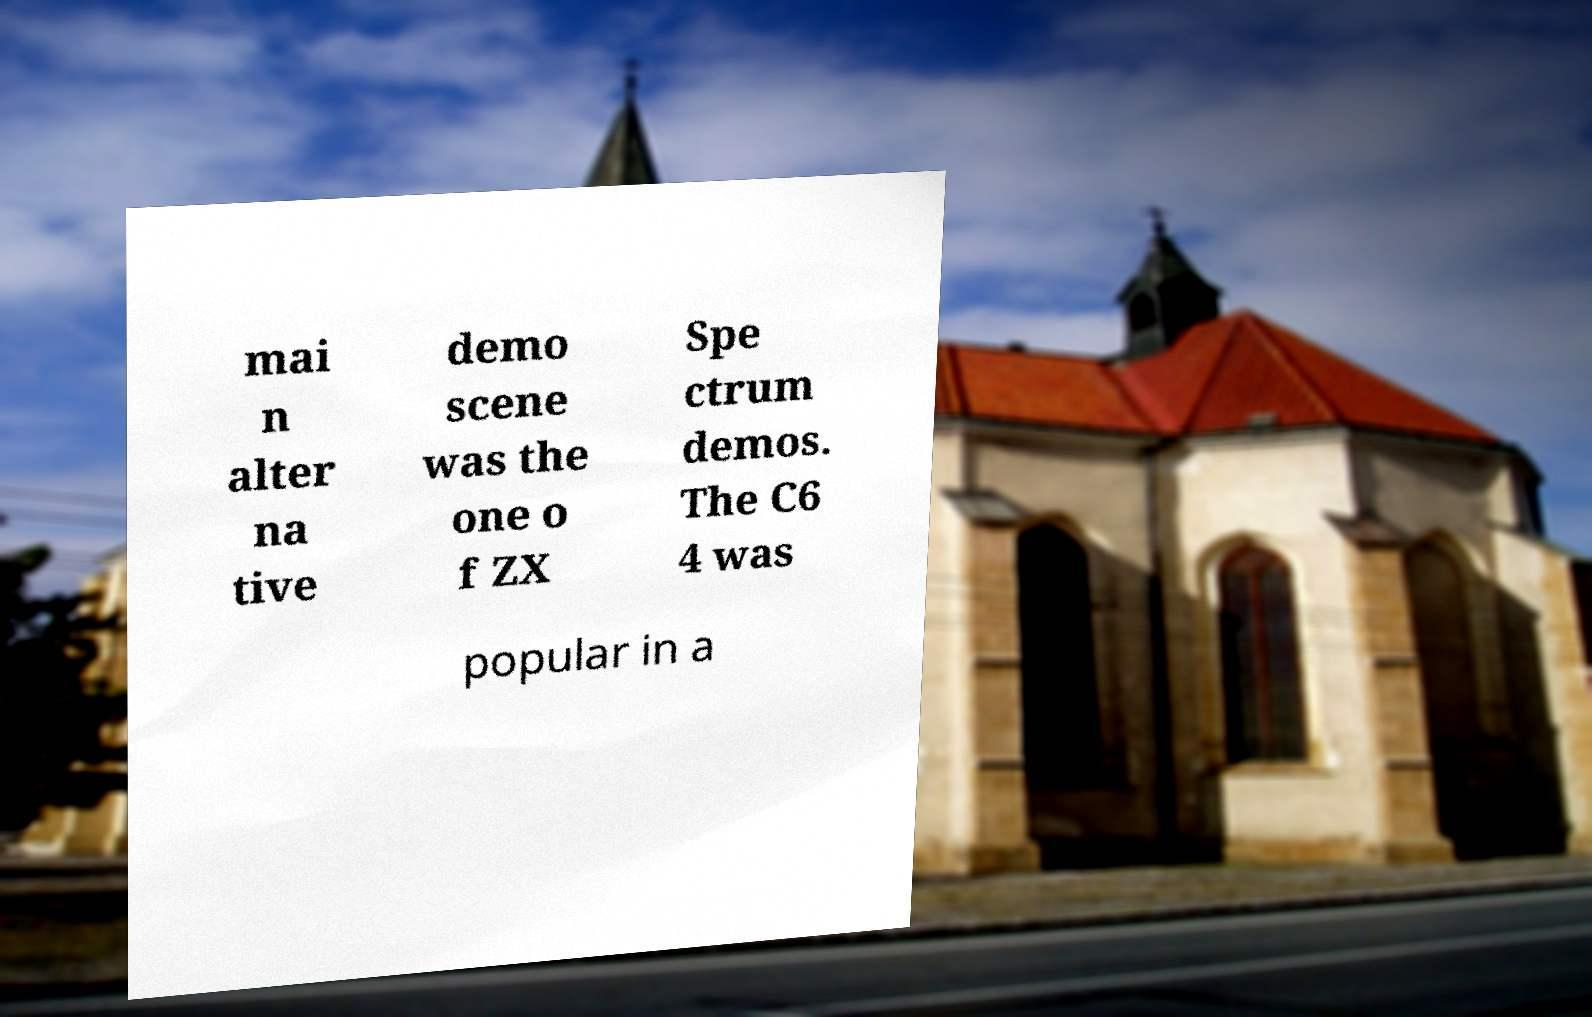Please identify and transcribe the text found in this image. mai n alter na tive demo scene was the one o f ZX Spe ctrum demos. The C6 4 was popular in a 